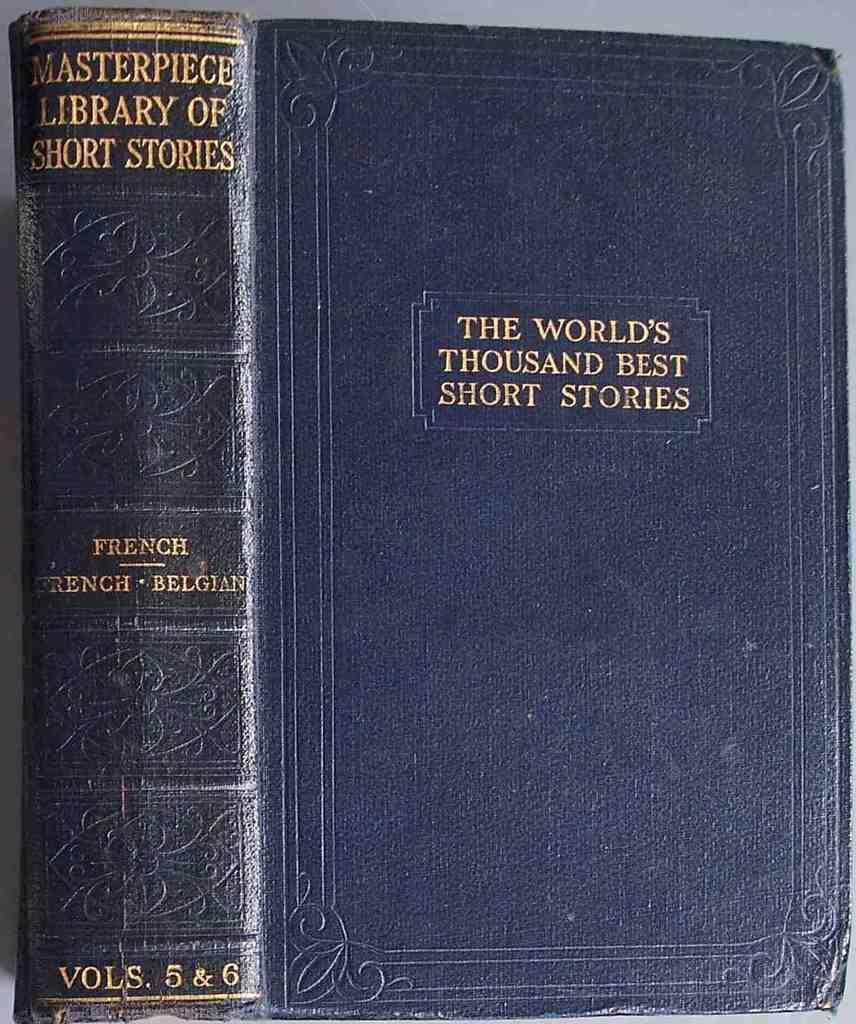<image>
Describe the image concisely. The black book is labeled The World's Thousand Best Short Stories. 